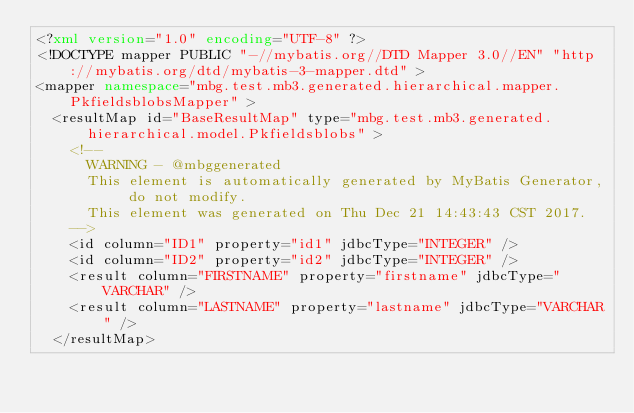<code> <loc_0><loc_0><loc_500><loc_500><_XML_><?xml version="1.0" encoding="UTF-8" ?>
<!DOCTYPE mapper PUBLIC "-//mybatis.org//DTD Mapper 3.0//EN" "http://mybatis.org/dtd/mybatis-3-mapper.dtd" >
<mapper namespace="mbg.test.mb3.generated.hierarchical.mapper.PkfieldsblobsMapper" >
  <resultMap id="BaseResultMap" type="mbg.test.mb3.generated.hierarchical.model.Pkfieldsblobs" >
    <!--
      WARNING - @mbggenerated
      This element is automatically generated by MyBatis Generator, do not modify.
      This element was generated on Thu Dec 21 14:43:43 CST 2017.
    -->
    <id column="ID1" property="id1" jdbcType="INTEGER" />
    <id column="ID2" property="id2" jdbcType="INTEGER" />
    <result column="FIRSTNAME" property="firstname" jdbcType="VARCHAR" />
    <result column="LASTNAME" property="lastname" jdbcType="VARCHAR" />
  </resultMap></code> 